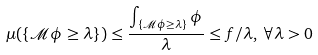<formula> <loc_0><loc_0><loc_500><loc_500>\mu ( \left \{ \mathcal { M \phi } \geq \lambda \right \} ) \leq \frac { \int _ { \left \{ \mathcal { M \phi } \geq \lambda \right \} } \phi } { \lambda } \leq f / \lambda , \, \forall \lambda > 0</formula> 